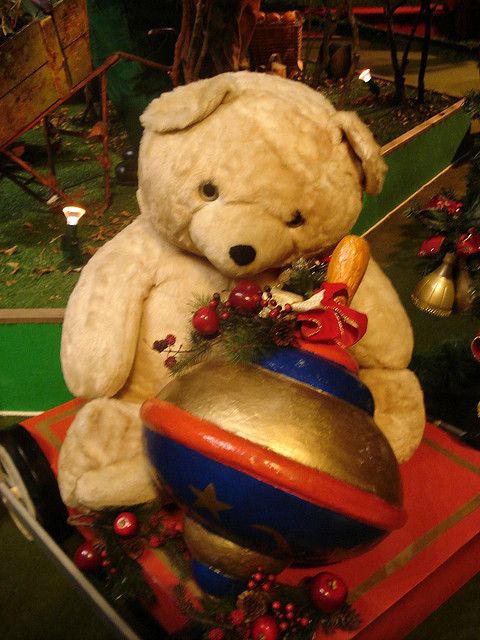What is the teddy bear holding? The teddy bear is not holding anything; however, it is seated next to a large, decorative Christmas bauble. 